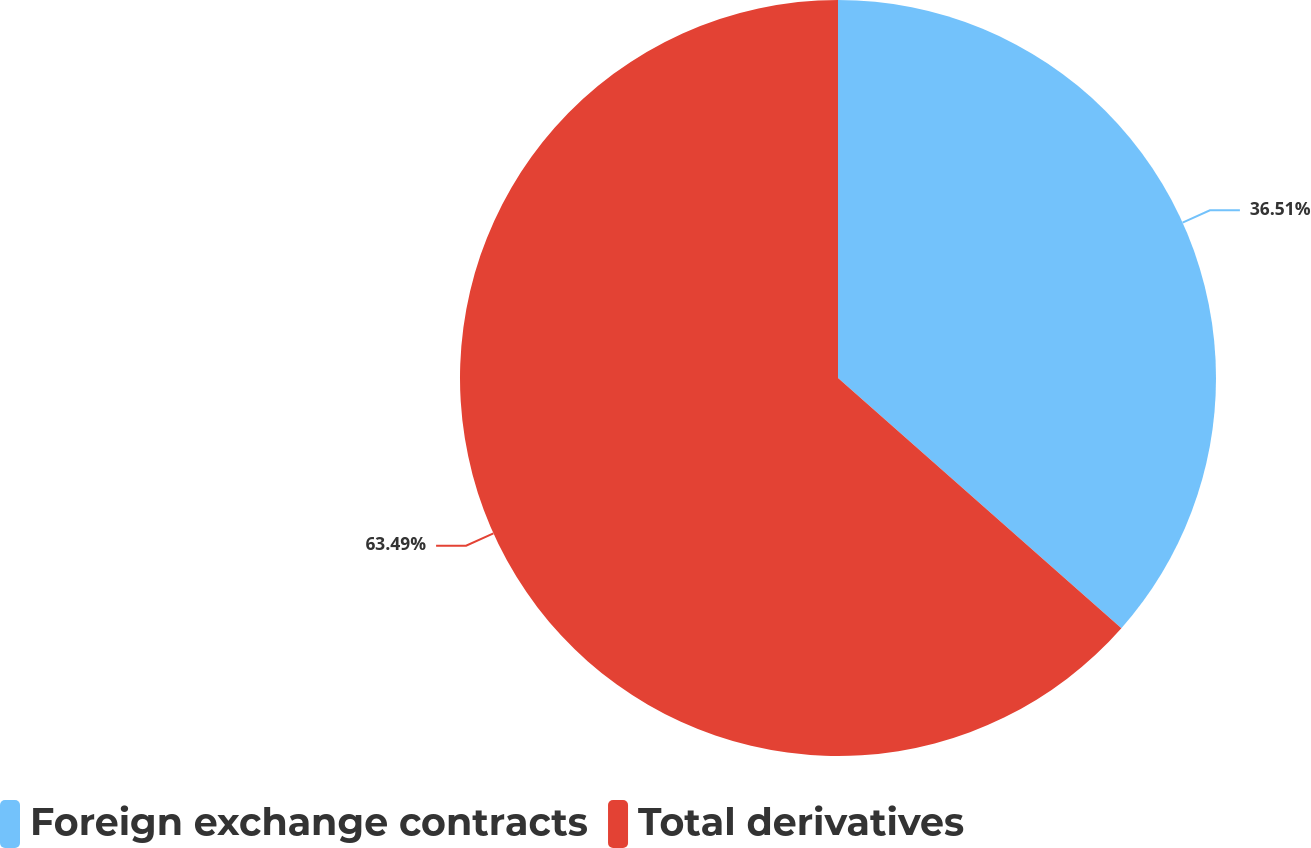<chart> <loc_0><loc_0><loc_500><loc_500><pie_chart><fcel>Foreign exchange contracts<fcel>Total derivatives<nl><fcel>36.51%<fcel>63.49%<nl></chart> 